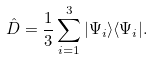Convert formula to latex. <formula><loc_0><loc_0><loc_500><loc_500>\hat { D } = \frac { 1 } { 3 } \sum _ { i = 1 } ^ { 3 } | \Psi _ { i } \rangle \langle \Psi _ { i } | .</formula> 